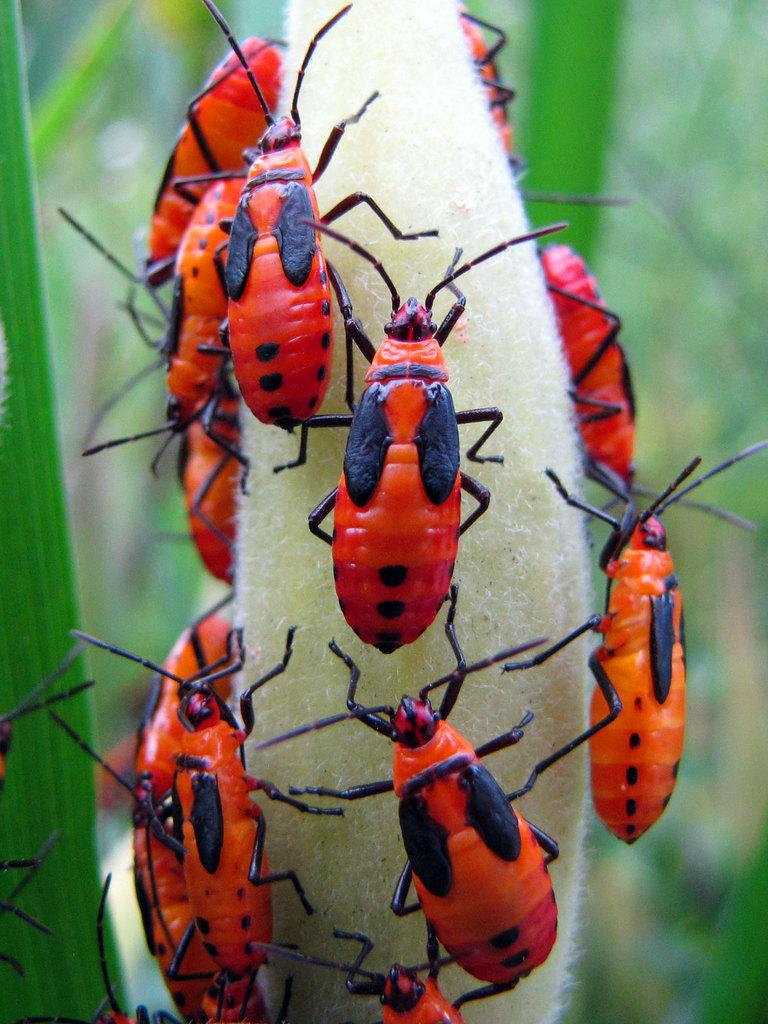What type of creatures are present in the image? There are many insects in the image. Can you describe the colors of the insects? The insects are orange, red, and black in color. What else can be seen in the image besides the insects? There are leaves in the image. How would you describe the background of the image? The background of the image is blurred. Where can the powder be found in the image? There is no powder present in the image. How many books are visible in the image? There are no books present in the image. 